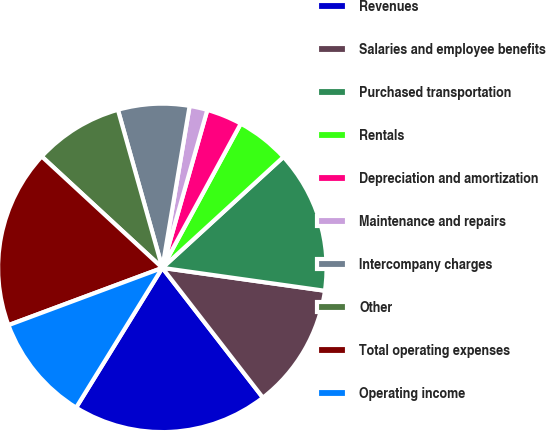Convert chart to OTSL. <chart><loc_0><loc_0><loc_500><loc_500><pie_chart><fcel>Revenues<fcel>Salaries and employee benefits<fcel>Purchased transportation<fcel>Rentals<fcel>Depreciation and amortization<fcel>Maintenance and repairs<fcel>Intercompany charges<fcel>Other<fcel>Total operating expenses<fcel>Operating income<nl><fcel>19.29%<fcel>12.28%<fcel>14.03%<fcel>5.27%<fcel>3.51%<fcel>1.76%<fcel>7.02%<fcel>8.77%<fcel>17.54%<fcel>10.53%<nl></chart> 